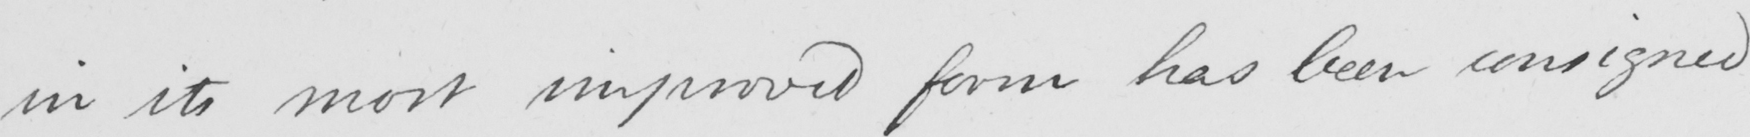Can you read and transcribe this handwriting? in its most improved form has been consigned 